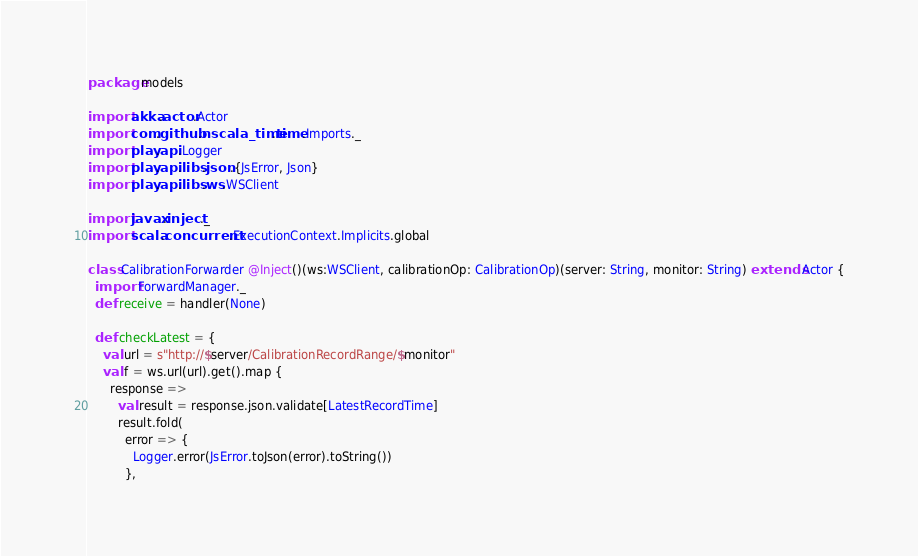Convert code to text. <code><loc_0><loc_0><loc_500><loc_500><_Scala_>package models

import akka.actor.Actor
import com.github.nscala_time.time.Imports._
import play.api.Logger
import play.api.libs.json.{JsError, Json}
import play.api.libs.ws.WSClient

import javax.inject._
import scala.concurrent.ExecutionContext.Implicits.global

class CalibrationForwarder @Inject()(ws:WSClient, calibrationOp: CalibrationOp)(server: String, monitor: String) extends Actor {
  import ForwardManager._
  def receive = handler(None)

  def checkLatest = {
    val url = s"http://$server/CalibrationRecordRange/$monitor"
    val f = ws.url(url).get().map {
      response =>
        val result = response.json.validate[LatestRecordTime]
        result.fold(
          error => {
            Logger.error(JsError.toJson(error).toString())
          },</code> 